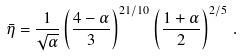<formula> <loc_0><loc_0><loc_500><loc_500>\bar { \eta } = \frac { 1 } { \sqrt { \alpha } } \left ( \frac { 4 - \alpha } { 3 } \right ) ^ { 2 1 / 1 0 } \left ( \frac { 1 + \alpha } { 2 } \right ) ^ { 2 / 5 } \, .</formula> 